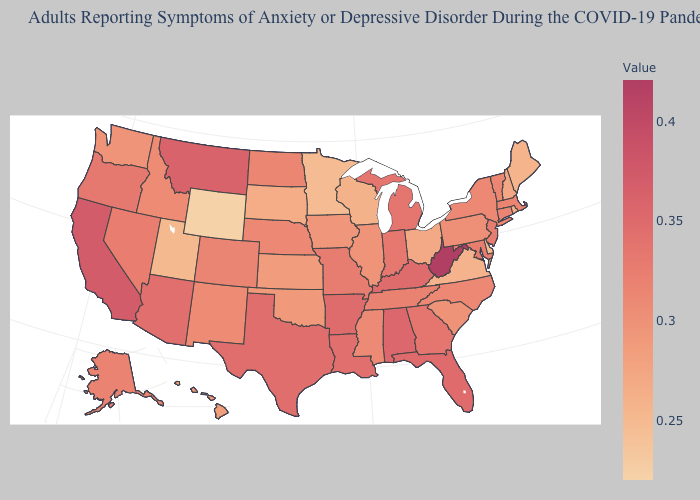Does the map have missing data?
Be succinct. No. Among the states that border West Virginia , which have the lowest value?
Be succinct. Virginia. Among the states that border Iowa , which have the highest value?
Short answer required. Missouri. 